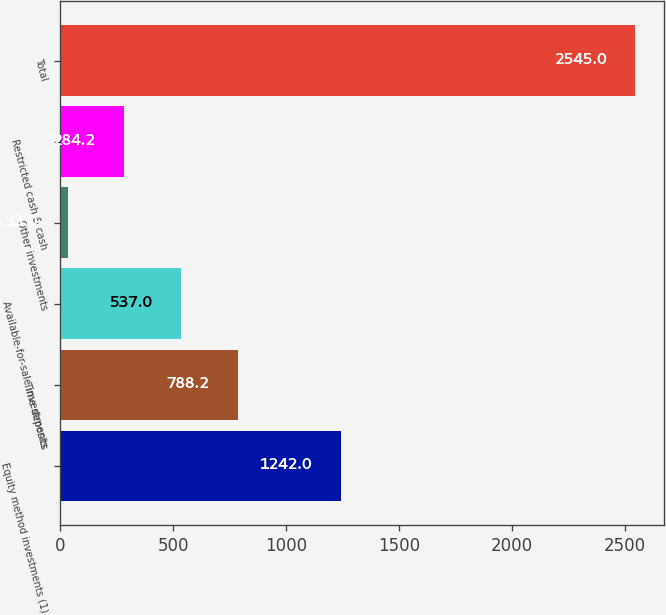<chart> <loc_0><loc_0><loc_500><loc_500><bar_chart><fcel>Equity method investments (1)<fcel>Time deposits<fcel>Available-for-sale investments<fcel>Other investments<fcel>Restricted cash & cash<fcel>Total<nl><fcel>1242<fcel>788.2<fcel>537<fcel>33<fcel>284.2<fcel>2545<nl></chart> 